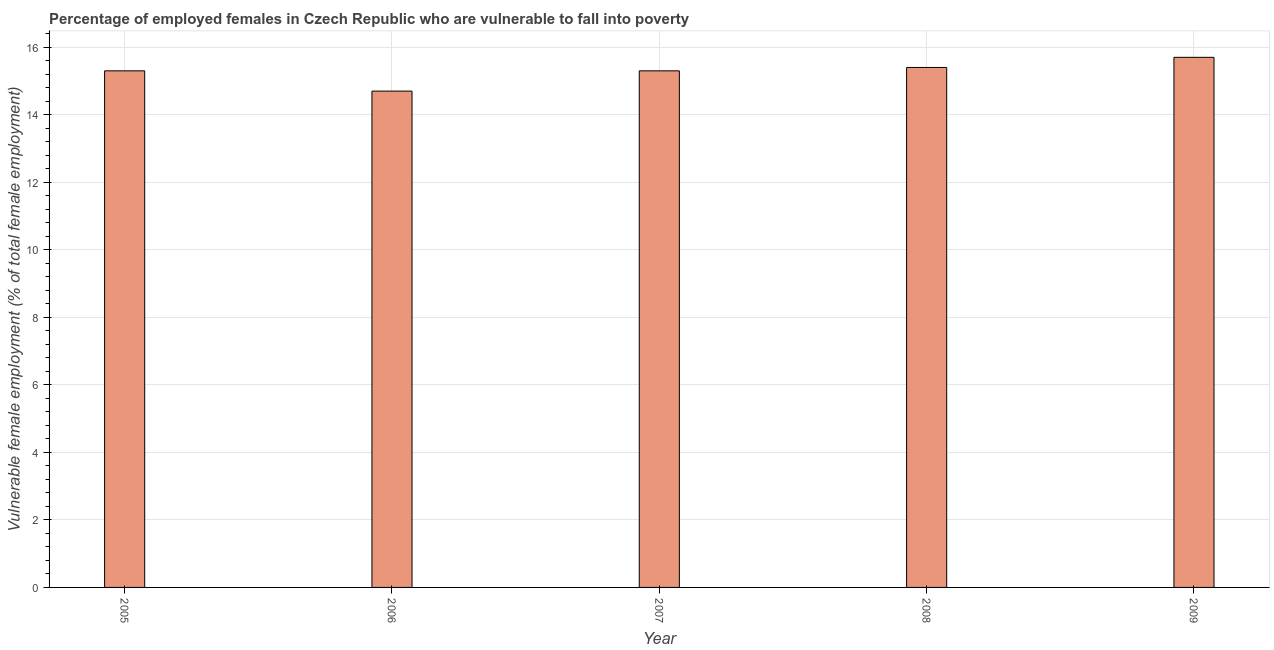Does the graph contain any zero values?
Your response must be concise. No. What is the title of the graph?
Offer a very short reply. Percentage of employed females in Czech Republic who are vulnerable to fall into poverty. What is the label or title of the X-axis?
Give a very brief answer. Year. What is the label or title of the Y-axis?
Offer a very short reply. Vulnerable female employment (% of total female employment). What is the percentage of employed females who are vulnerable to fall into poverty in 2009?
Your response must be concise. 15.7. Across all years, what is the maximum percentage of employed females who are vulnerable to fall into poverty?
Your answer should be compact. 15.7. Across all years, what is the minimum percentage of employed females who are vulnerable to fall into poverty?
Provide a succinct answer. 14.7. In which year was the percentage of employed females who are vulnerable to fall into poverty maximum?
Make the answer very short. 2009. In which year was the percentage of employed females who are vulnerable to fall into poverty minimum?
Make the answer very short. 2006. What is the sum of the percentage of employed females who are vulnerable to fall into poverty?
Provide a succinct answer. 76.4. What is the average percentage of employed females who are vulnerable to fall into poverty per year?
Give a very brief answer. 15.28. What is the median percentage of employed females who are vulnerable to fall into poverty?
Keep it short and to the point. 15.3. Do a majority of the years between 2009 and 2006 (inclusive) have percentage of employed females who are vulnerable to fall into poverty greater than 12.4 %?
Give a very brief answer. Yes. What is the ratio of the percentage of employed females who are vulnerable to fall into poverty in 2006 to that in 2009?
Give a very brief answer. 0.94. Is the percentage of employed females who are vulnerable to fall into poverty in 2005 less than that in 2008?
Make the answer very short. Yes. Is the sum of the percentage of employed females who are vulnerable to fall into poverty in 2006 and 2009 greater than the maximum percentage of employed females who are vulnerable to fall into poverty across all years?
Provide a succinct answer. Yes. Are the values on the major ticks of Y-axis written in scientific E-notation?
Keep it short and to the point. No. What is the Vulnerable female employment (% of total female employment) in 2005?
Provide a short and direct response. 15.3. What is the Vulnerable female employment (% of total female employment) of 2006?
Your answer should be very brief. 14.7. What is the Vulnerable female employment (% of total female employment) of 2007?
Ensure brevity in your answer.  15.3. What is the Vulnerable female employment (% of total female employment) in 2008?
Offer a terse response. 15.4. What is the Vulnerable female employment (% of total female employment) in 2009?
Your answer should be compact. 15.7. What is the difference between the Vulnerable female employment (% of total female employment) in 2005 and 2008?
Make the answer very short. -0.1. What is the difference between the Vulnerable female employment (% of total female employment) in 2005 and 2009?
Your response must be concise. -0.4. What is the difference between the Vulnerable female employment (% of total female employment) in 2007 and 2008?
Keep it short and to the point. -0.1. What is the difference between the Vulnerable female employment (% of total female employment) in 2007 and 2009?
Ensure brevity in your answer.  -0.4. What is the ratio of the Vulnerable female employment (% of total female employment) in 2005 to that in 2006?
Offer a very short reply. 1.04. What is the ratio of the Vulnerable female employment (% of total female employment) in 2005 to that in 2007?
Keep it short and to the point. 1. What is the ratio of the Vulnerable female employment (% of total female employment) in 2006 to that in 2008?
Give a very brief answer. 0.95. What is the ratio of the Vulnerable female employment (% of total female employment) in 2006 to that in 2009?
Offer a very short reply. 0.94. What is the ratio of the Vulnerable female employment (% of total female employment) in 2007 to that in 2008?
Ensure brevity in your answer.  0.99. What is the ratio of the Vulnerable female employment (% of total female employment) in 2008 to that in 2009?
Ensure brevity in your answer.  0.98. 